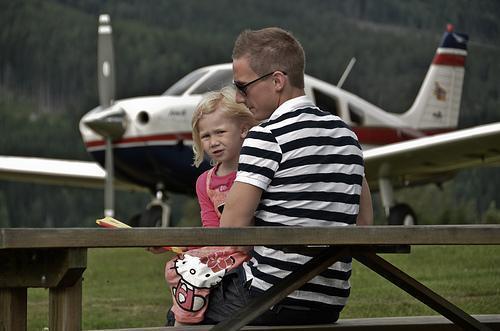How many people are pictured here?
Give a very brief answer. 2. 